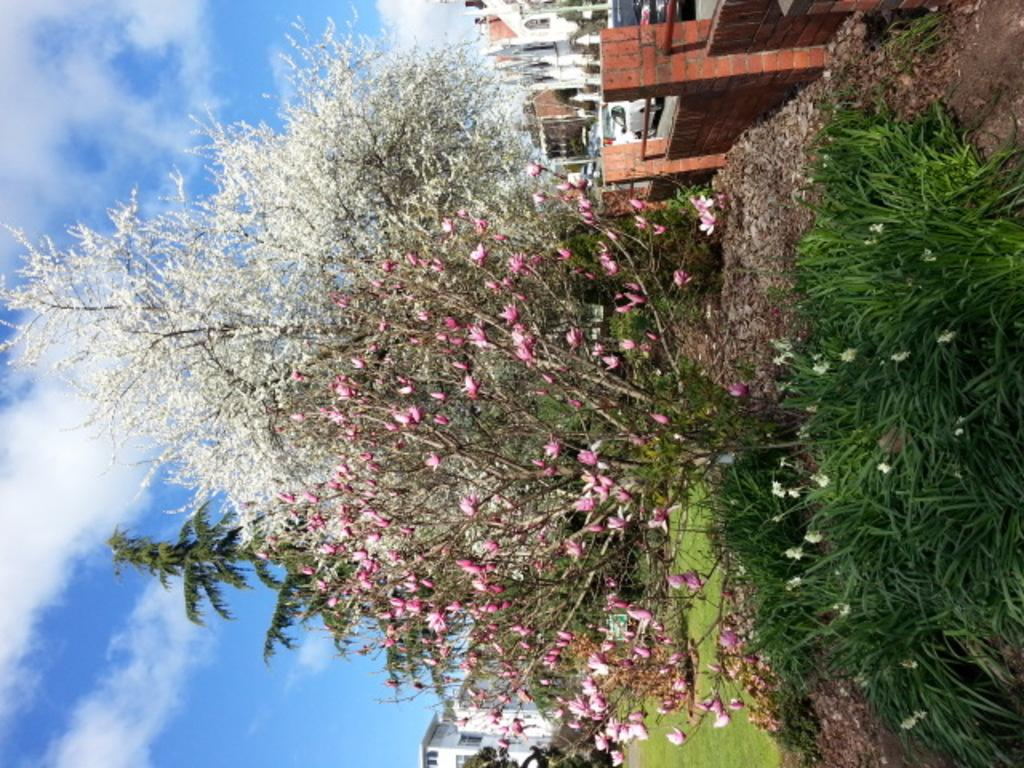What type of vegetation is present on the ground in the image? There are plants and trees on the ground in the image. What structures can be seen in the background of the image? There are buildings in the background of the image. What part of the natural environment is visible in the image? The sky is visible in the image. What type of plot is being attacked by the creatures in the image? There are no creatures or plots present in the image; it features plants, trees, buildings, and the sky. What type of journey can be seen taking place in the image? There is no journey depicted in the image; it shows a static scene with plants, trees, buildings, and the sky. 